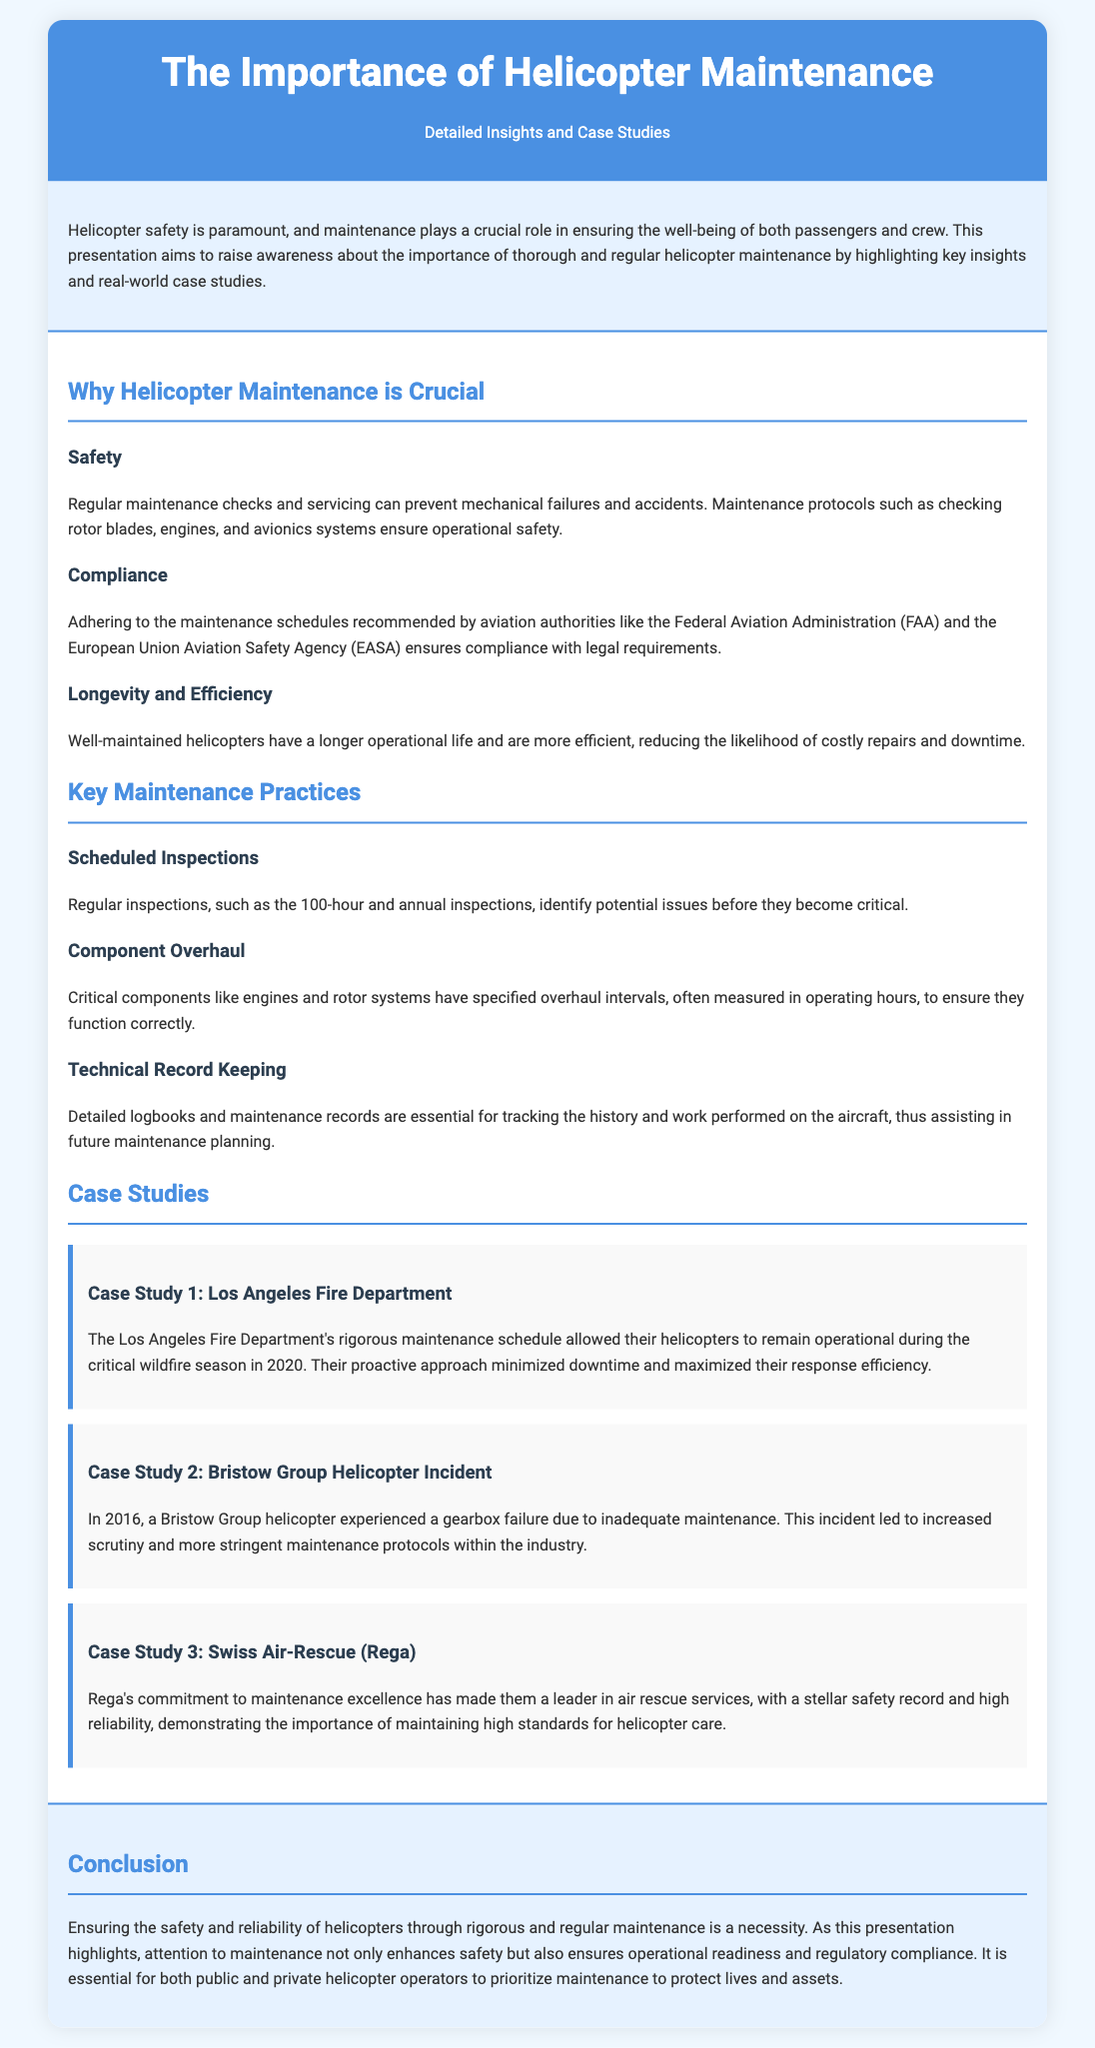What are the two aviation authorities mentioned? The document mentions the FAA and EASA as aviation authorities.
Answer: FAA, EASA What is a key maintenance practice mentioned? The document outlines scheduled inspections as a key maintenance practice.
Answer: Scheduled Inspections What year did the Bristow Group helicopter incident occur? The incident involving the Bristow Group helicopter happened in 2016.
Answer: 2016 What is the main focus of the presentation? The presentation primarily targets the importance of helicopter maintenance for safety and reliability.
Answer: Helicopter Maintenance Which organization's maintenance schedule helped during the wildfire season? The Los Angeles Fire Department's maintenance schedule was crucial during the wildfire season.
Answer: Los Angeles Fire Department What specific maintenance record is emphasized in the document? The document highlights the importance of technical record keeping for maintenance tracking.
Answer: Technical Record Keeping What is the outcome of Rega's commitment to maintenance? Rega's commitment has resulted in a stellar safety record and high reliability.
Answer: Stellar safety record What is one effect of inadequate maintenance mentioned in the case studies? The inadequate maintenance led to increased scrutiny and more stringent protocols within the industry.
Answer: Increased scrutiny What type of document is this presentation categorized as? This document is categorized as a presentation slide focused on helicopter maintenance.
Answer: Presentation slide 